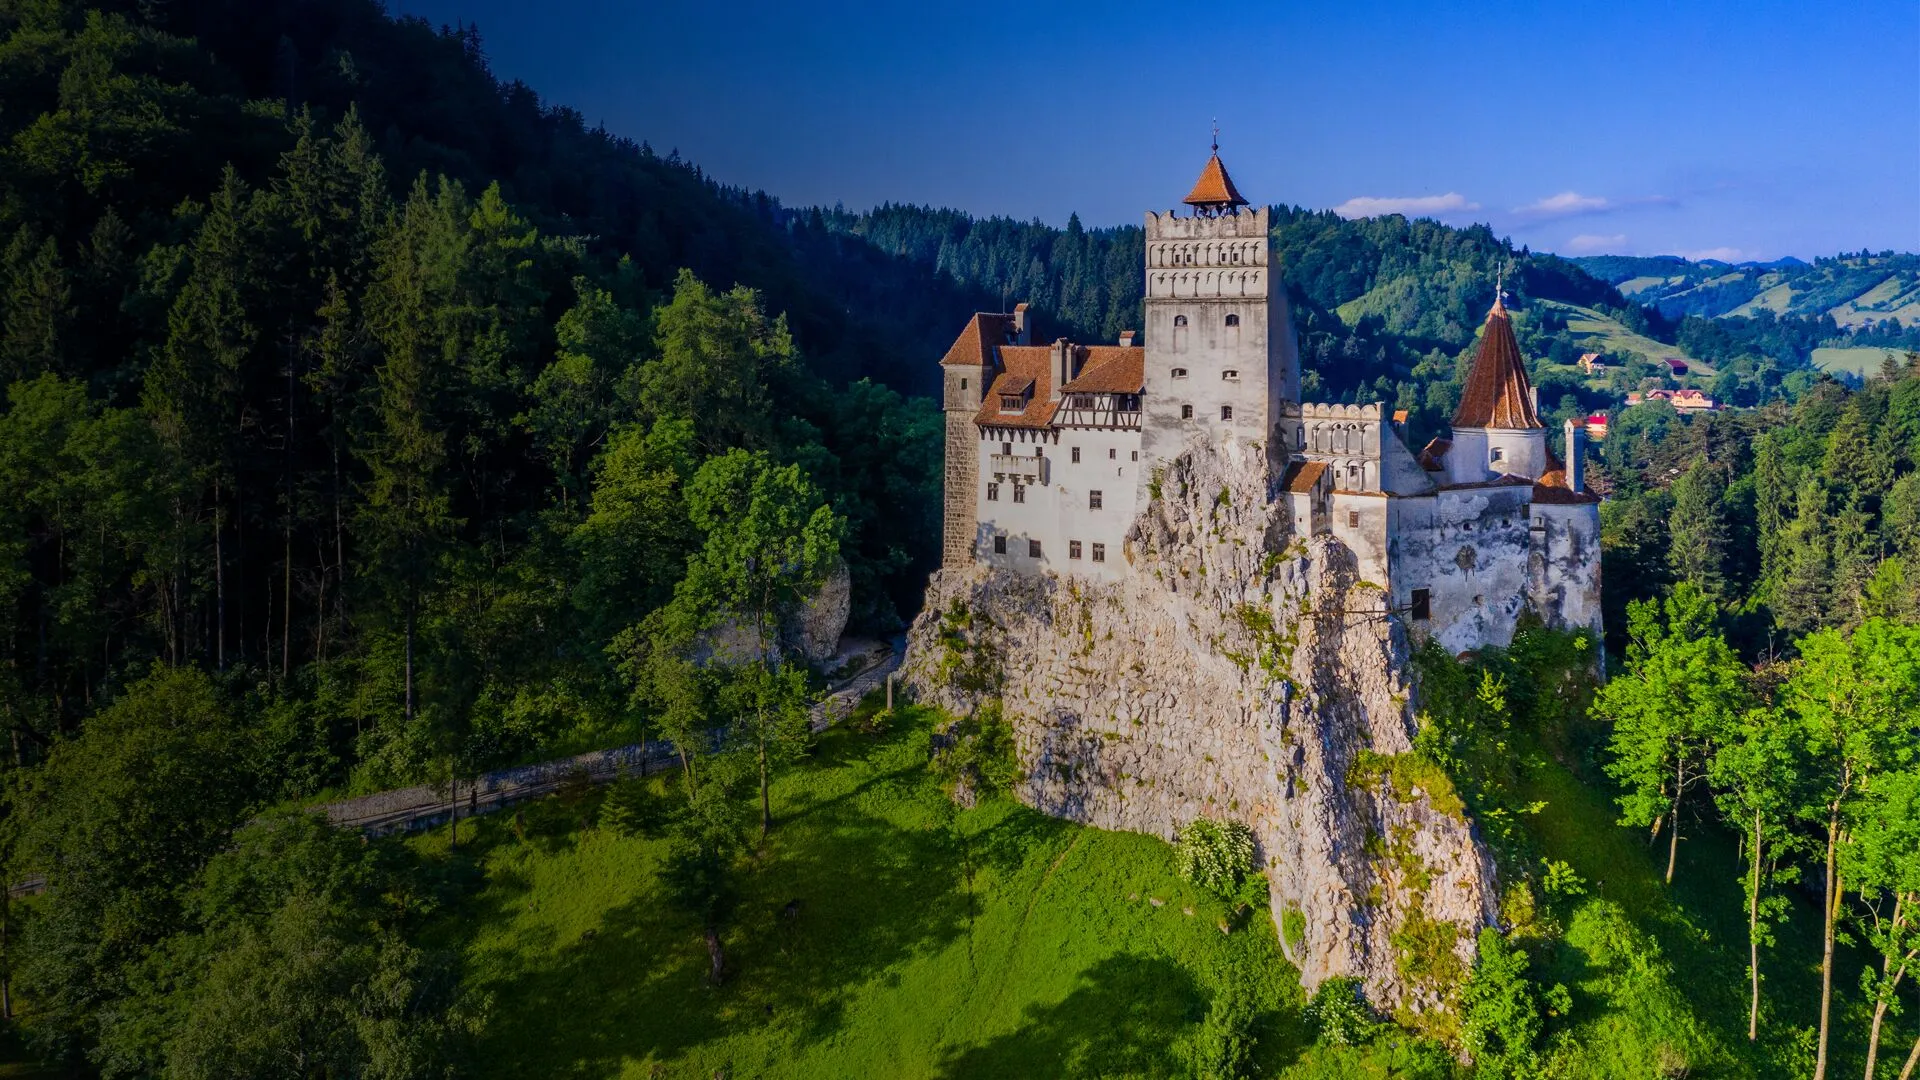What would it feel like to explore the hidden passages of the castle? Exploring the hidden passages of Bran Castle would be like stepping into a realm of mystery and excitement. The dim lighting and stone walls would evoke a sense of being back in medieval times, with history seemingly whispering through the corridors. Narrow and winding, these secret paths would open up into small hidden chambers, perhaps used by guards or even for secret meetings. Every turn and shadow would hold the promise of discovering something new – an ancient tapestry, a secret doorway, or a forgotten artifact. The air would be cool, carrying the faint scent of aged wood and stone, adding to the atmosphere of exploration and adventure. 